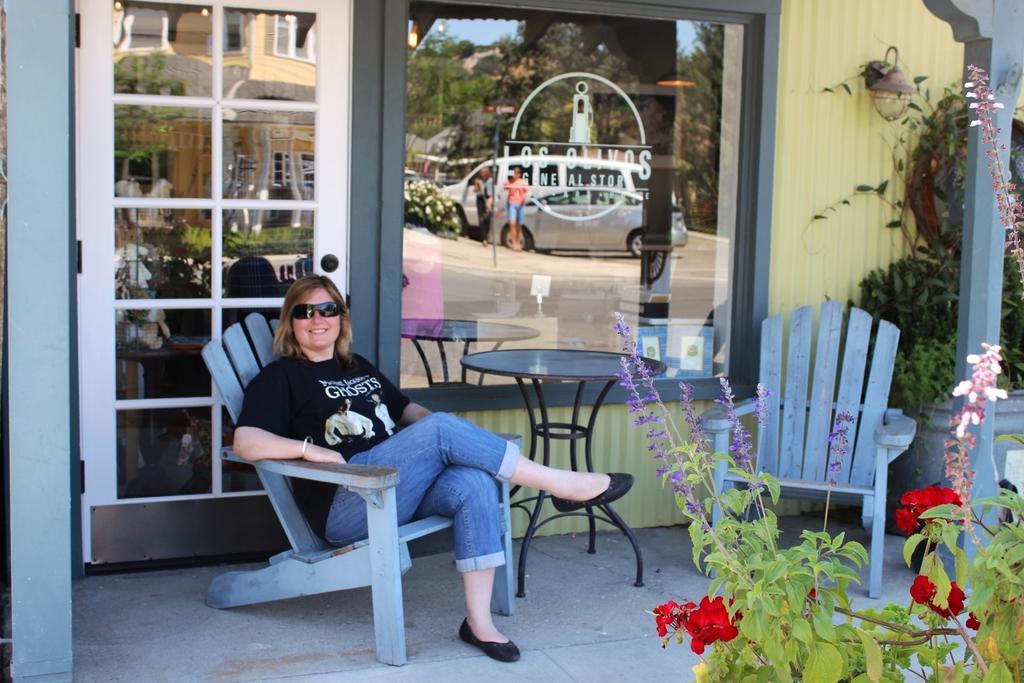Can you describe this image briefly? In this Image I see a woman who is sitting and I can also see that she is smiling. I see that there are 2 chairs and a table over here and i see few plants. In the background I see the glass in which I see 2 cars, trees and 2 persons over here. 